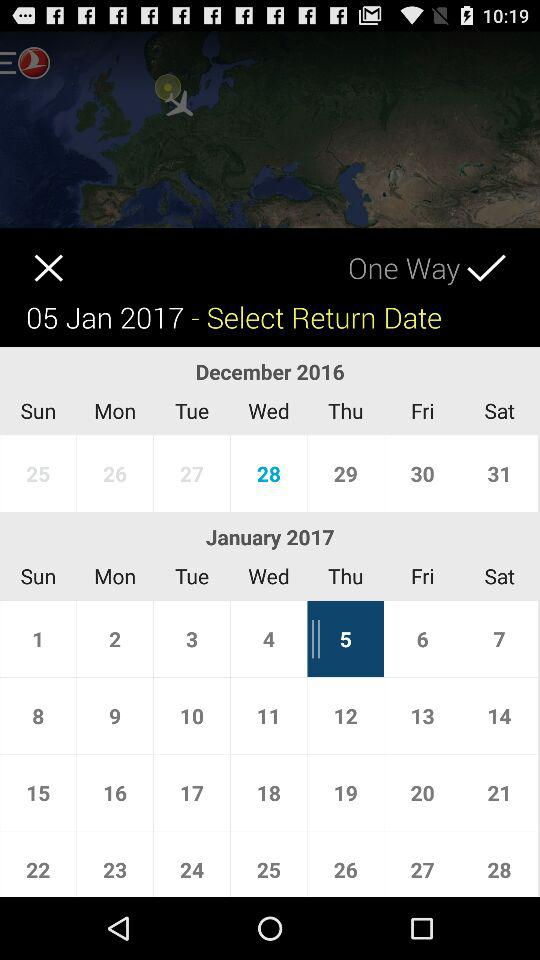What is the return date?
When the provided information is insufficient, respond with <no answer>. <no answer> 